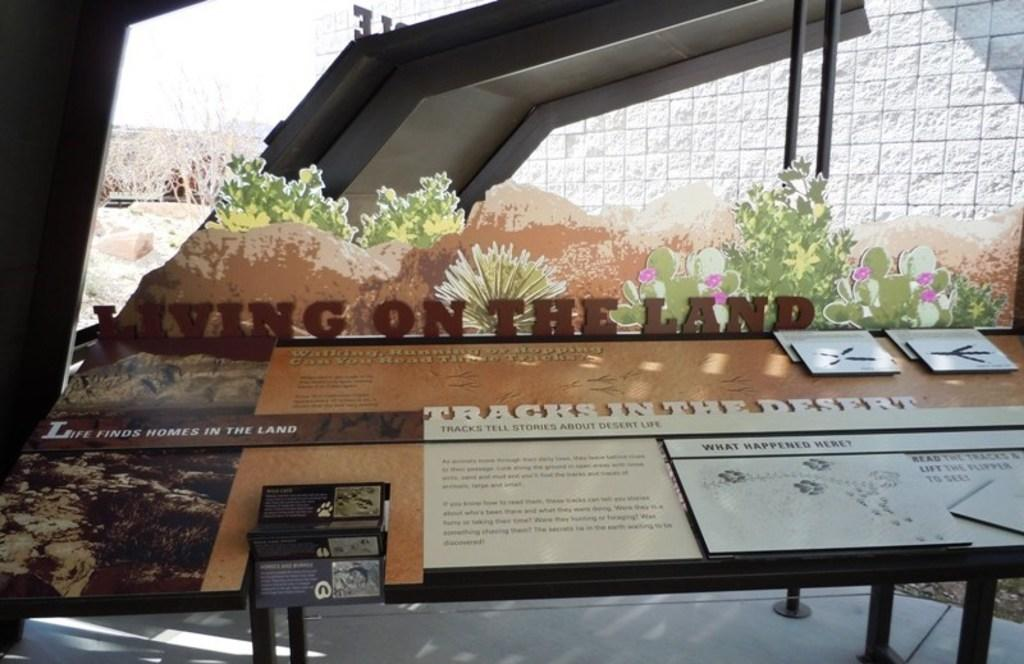What type of structure is visible in the image? There is a building wall in the image. What natural elements can be seen in the image? There are trees and painted hills visible in the image. What man-made object with text is present in the image? There is a board with text in the image. What type of vegetation is present in the image? Plants are present in the image. What flavor of ice cream is being served at the birth of the child in the image? There is no ice cream or child present in the image, so it is not possible to answer that question. 